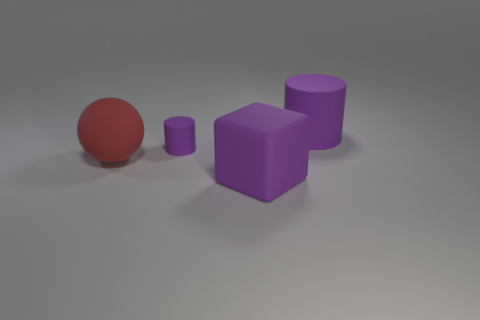Subtract 1 cylinders. How many cylinders are left? 1 Subtract 0 blue cylinders. How many objects are left? 4 Subtract all blocks. How many objects are left? 3 Subtract all blue balls. Subtract all cyan blocks. How many balls are left? 1 Subtract all purple cylinders. Subtract all green spheres. How many objects are left? 2 Add 4 large balls. How many large balls are left? 5 Add 2 tiny gray shiny objects. How many tiny gray shiny objects exist? 2 Add 2 big purple rubber objects. How many objects exist? 6 